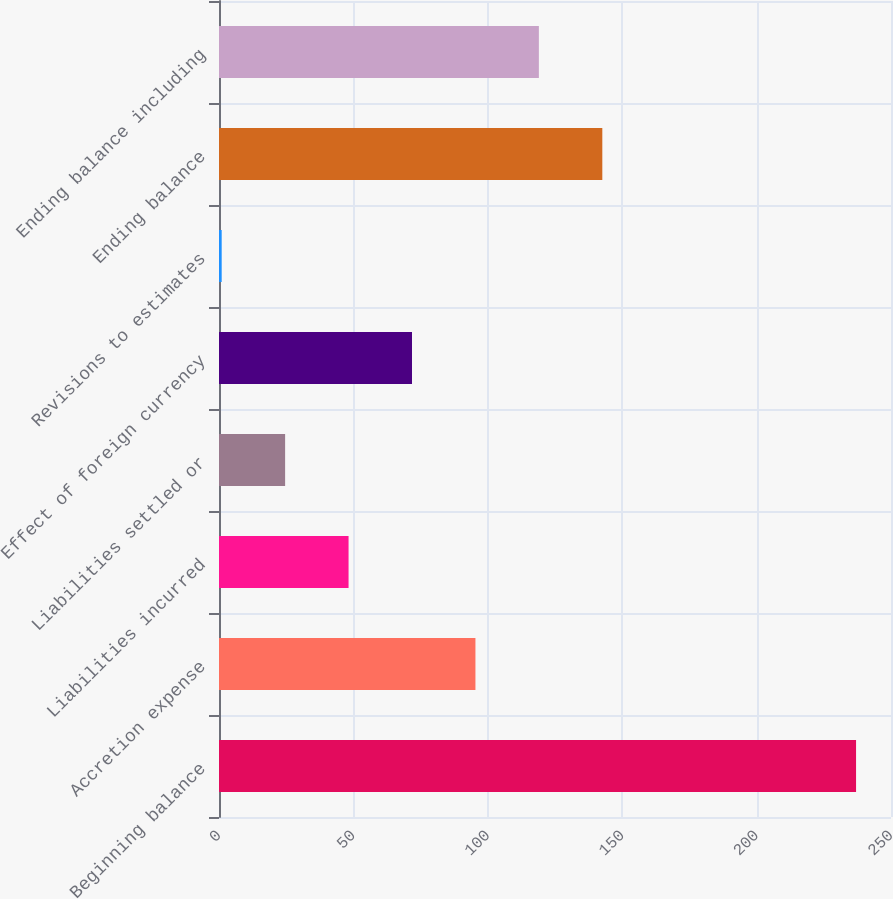Convert chart. <chart><loc_0><loc_0><loc_500><loc_500><bar_chart><fcel>Beginning balance<fcel>Accretion expense<fcel>Liabilities incurred<fcel>Liabilities settled or<fcel>Effect of foreign currency<fcel>Revisions to estimates<fcel>Ending balance<fcel>Ending balance including<nl><fcel>237<fcel>95.4<fcel>48.2<fcel>24.6<fcel>71.8<fcel>1<fcel>142.6<fcel>119<nl></chart> 